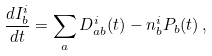Convert formula to latex. <formula><loc_0><loc_0><loc_500><loc_500>\frac { d I _ { b } ^ { i } } { d t } = \sum _ { a } D _ { a b } ^ { i } ( t ) - n _ { b } ^ { i } P _ { b } ( t ) \, ,</formula> 